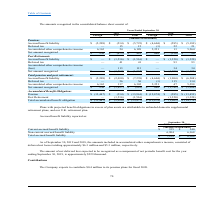According to Csp's financial document, What is the amount of net deferred loss expected to be recognized as a component of net periodic benefit cost for the year ending September 30, 2019? According to the financial document, $229 thousand. The relevant text states: "ending September 30, 2019, is approximately $229 thousand...." Also, What is the amount included in accumulated other comprehensive income as of September 30, 2019? According to the financial document, $6.3 million. The relevant text states: "deferred net losses totaling approximately $6.3 million and $5.3 million, respectively...." Also, What is the amount included in accumulated other comprehensive income as of September 30, 2018? According to the financial document, $5.3 million. The relevant text states: "net losses totaling approximately $6.3 million and $5.3 million, respectively...." Also, can you calculate: What is the percentage change in the current accrued benefit liability between 2018 and 2019? To answer this question, I need to perform calculations using the financial data. The calculation is: (335 - 340)/340 , which equals -1.47 (percentage). This is based on the information: "Current accrued benefit liability $ 335 $ 340 Current accrued benefit liability $ 335 $ 340..." The key data points involved are: 335, 340. Also, can you calculate: What is the change in non-current accrued benefit liability between 2018 and 2019? Based on the calculation: 6,904 - 6,168 , the result is 736 (in thousands). This is based on the information: "Non-current accrued benefit liability 6,904 6,168 Non-current accrued benefit liability 6,904 6,168..." The key data points involved are: 6,168, 6,904. Also, can you calculate: How much is the current accrued benefit liability as a percentage of the total accrued benefit liability in 2019? Based on the calculation: 335/7,239 , the result is 4.63 (percentage). This is based on the information: "Current accrued benefit liability $ 335 $ 340 Accrued benefit liability $ (5,209) $ (2,030) $ (7,239) $ (4,604) $ (1,904) $ (6,508)..." The key data points involved are: 335, 7,239. 